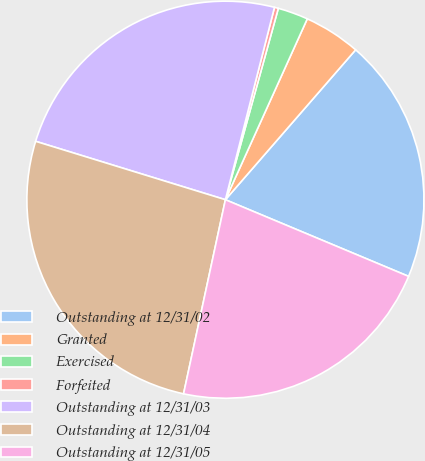Convert chart to OTSL. <chart><loc_0><loc_0><loc_500><loc_500><pie_chart><fcel>Outstanding at 12/31/02<fcel>Granted<fcel>Exercised<fcel>Forfeited<fcel>Outstanding at 12/31/03<fcel>Outstanding at 12/31/04<fcel>Outstanding at 12/31/05<nl><fcel>19.92%<fcel>4.62%<fcel>2.47%<fcel>0.32%<fcel>24.22%<fcel>26.37%<fcel>22.07%<nl></chart> 